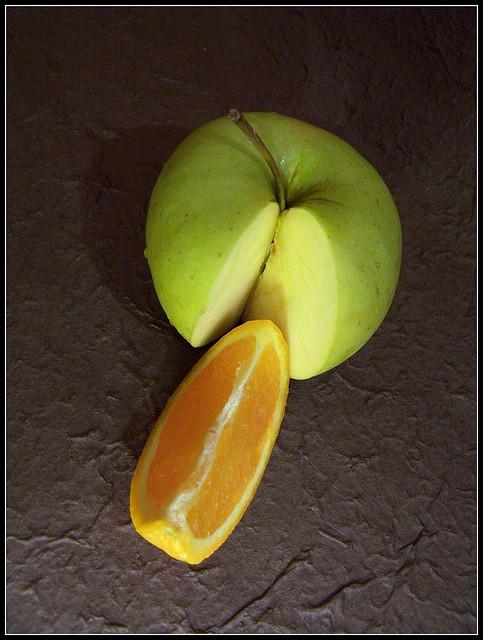How many fruits are there?
Give a very brief answer. 2. How many slices of oranges it there?
Write a very short answer. 1. Is there a seed in the apple?
Quick response, please. Yes. 